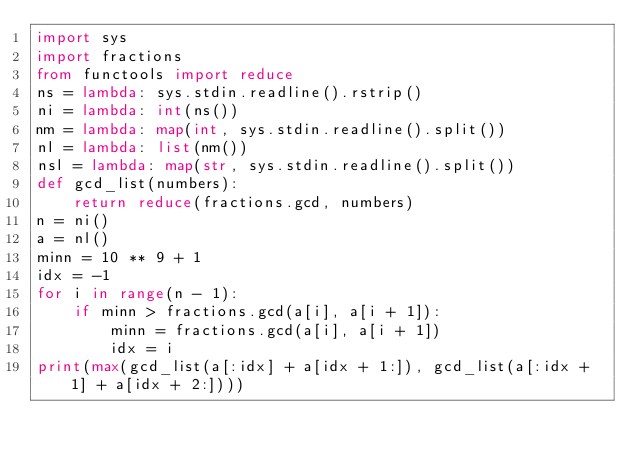Convert code to text. <code><loc_0><loc_0><loc_500><loc_500><_Python_>import sys
import fractions
from functools import reduce
ns = lambda: sys.stdin.readline().rstrip()
ni = lambda: int(ns())
nm = lambda: map(int, sys.stdin.readline().split())
nl = lambda: list(nm())
nsl = lambda: map(str, sys.stdin.readline().split())
def gcd_list(numbers):
    return reduce(fractions.gcd, numbers)
n = ni()
a = nl()
minn = 10 ** 9 + 1
idx = -1
for i in range(n - 1):
    if minn > fractions.gcd(a[i], a[i + 1]):
        minn = fractions.gcd(a[i], a[i + 1])
        idx = i
print(max(gcd_list(a[:idx] + a[idx + 1:]), gcd_list(a[:idx + 1] + a[idx + 2:])))
</code> 